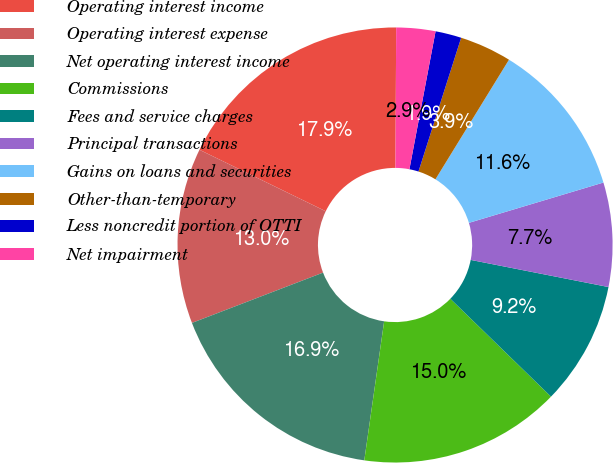Convert chart. <chart><loc_0><loc_0><loc_500><loc_500><pie_chart><fcel>Operating interest income<fcel>Operating interest expense<fcel>Net operating interest income<fcel>Commissions<fcel>Fees and service charges<fcel>Principal transactions<fcel>Gains on loans and securities<fcel>Other-than-temporary<fcel>Less noncredit portion of OTTI<fcel>Net impairment<nl><fcel>17.87%<fcel>13.04%<fcel>16.91%<fcel>14.98%<fcel>9.18%<fcel>7.73%<fcel>11.59%<fcel>3.86%<fcel>1.93%<fcel>2.9%<nl></chart> 